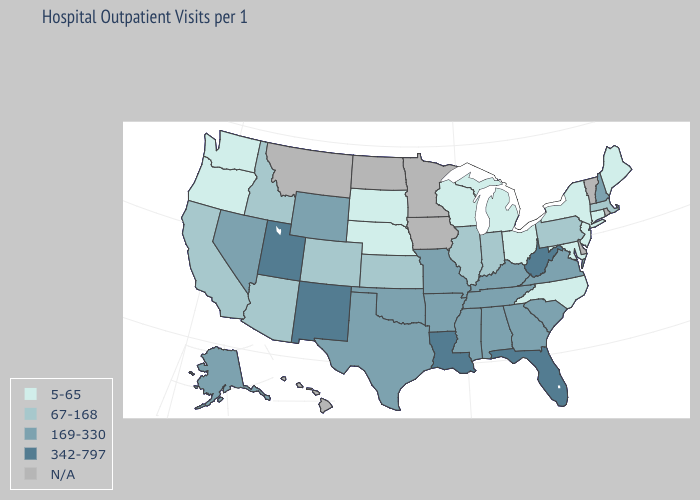Which states have the highest value in the USA?
Short answer required. Florida, Louisiana, New Mexico, Utah, West Virginia. Name the states that have a value in the range N/A?
Keep it brief. Delaware, Hawaii, Iowa, Minnesota, Montana, North Dakota, Rhode Island, Vermont. What is the highest value in the West ?
Give a very brief answer. 342-797. What is the value of Utah?
Be succinct. 342-797. Does the first symbol in the legend represent the smallest category?
Be succinct. Yes. What is the value of Mississippi?
Answer briefly. 169-330. What is the value of South Carolina?
Short answer required. 169-330. Does New Mexico have the highest value in the USA?
Give a very brief answer. Yes. What is the value of Oregon?
Write a very short answer. 5-65. Does West Virginia have the highest value in the USA?
Answer briefly. Yes. Name the states that have a value in the range N/A?
Give a very brief answer. Delaware, Hawaii, Iowa, Minnesota, Montana, North Dakota, Rhode Island, Vermont. What is the lowest value in the USA?
Quick response, please. 5-65. What is the highest value in states that border Wisconsin?
Answer briefly. 67-168. What is the lowest value in the MidWest?
Quick response, please. 5-65. Does North Carolina have the lowest value in the USA?
Concise answer only. Yes. 